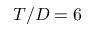Convert formula to latex. <formula><loc_0><loc_0><loc_500><loc_500>T / D = 6</formula> 